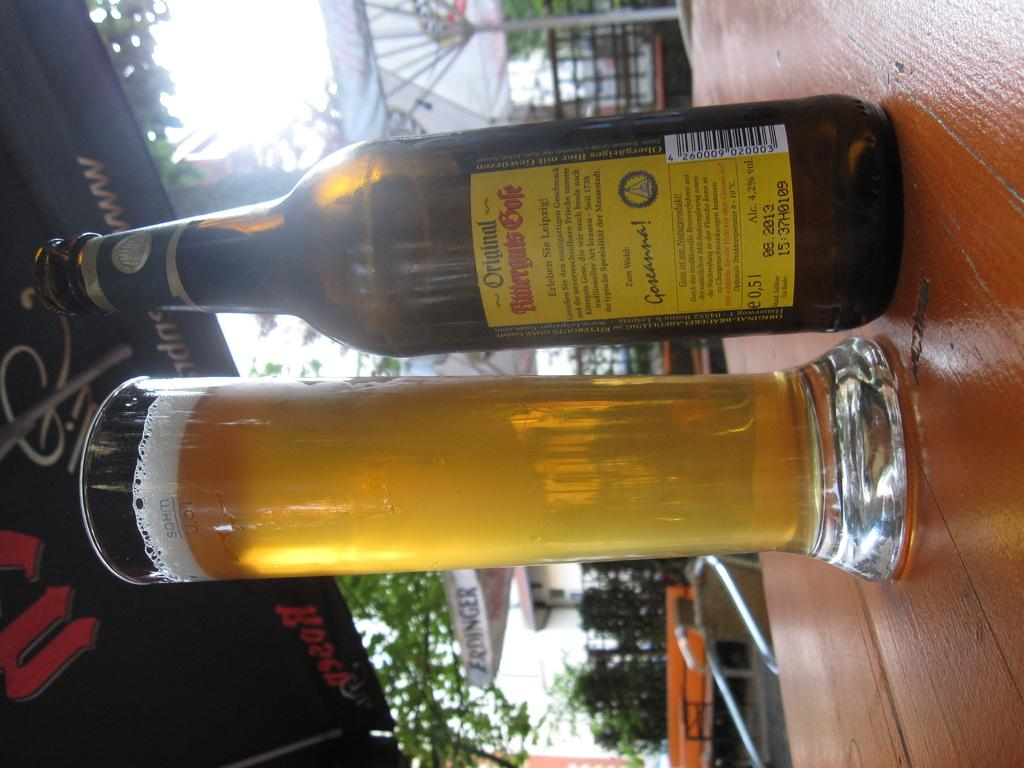<image>
Summarize the visual content of the image. a tall beer glass with a bottle of an original kind next to it 